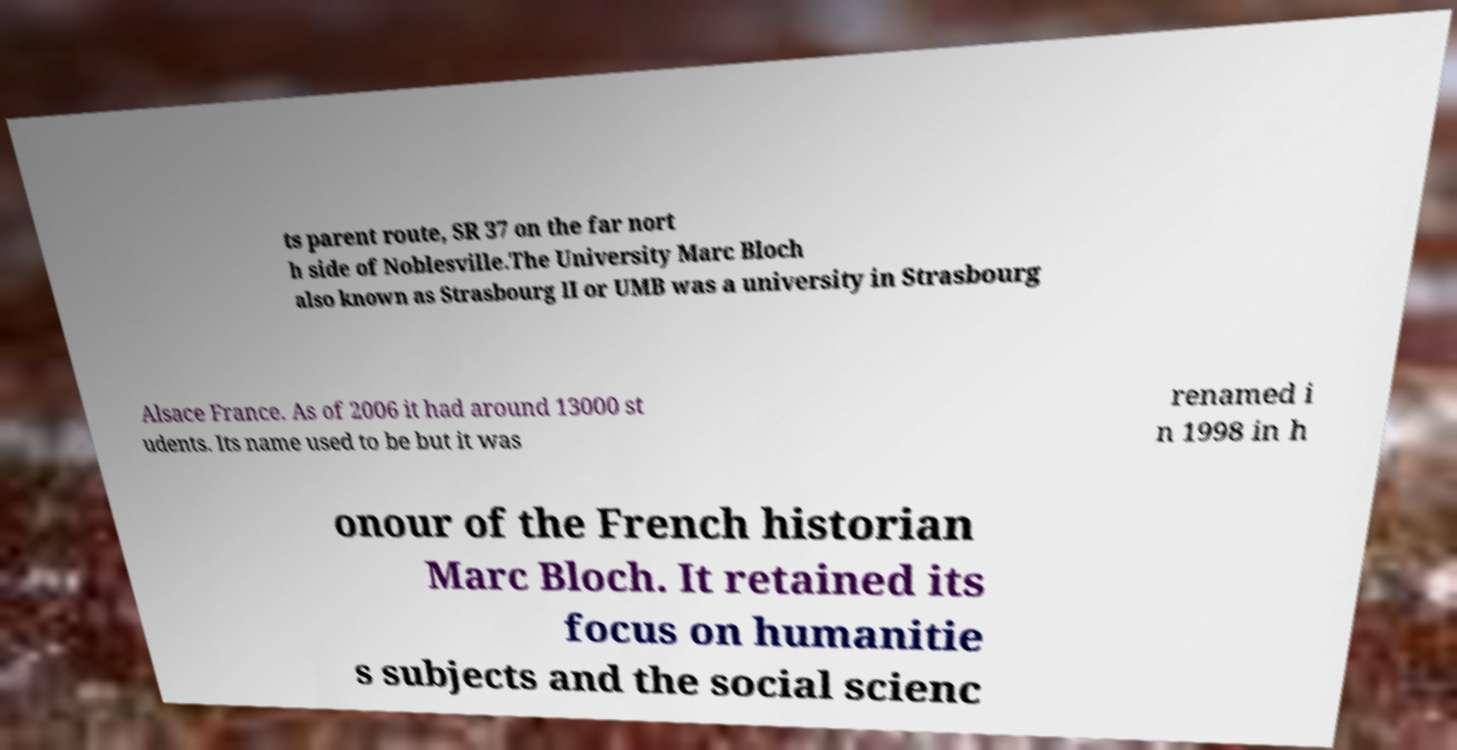Please identify and transcribe the text found in this image. ts parent route, SR 37 on the far nort h side of Noblesville.The University Marc Bloch also known as Strasbourg II or UMB was a university in Strasbourg Alsace France. As of 2006 it had around 13000 st udents. Its name used to be but it was renamed i n 1998 in h onour of the French historian Marc Bloch. It retained its focus on humanitie s subjects and the social scienc 